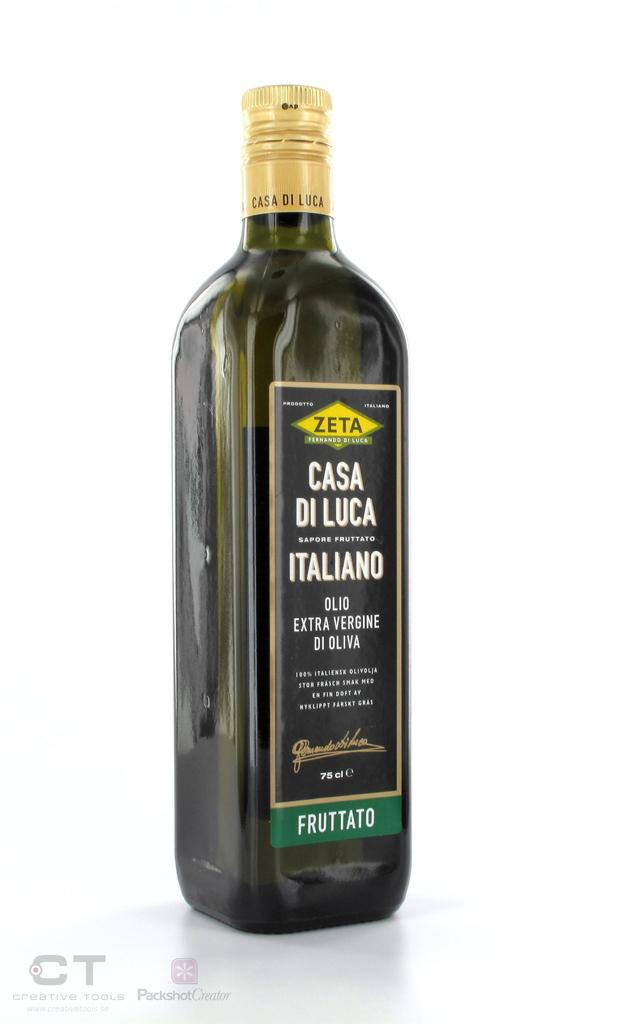Provide a one-sentence caption for the provided image. A bottle of Zeta extra virgin olive oil. 